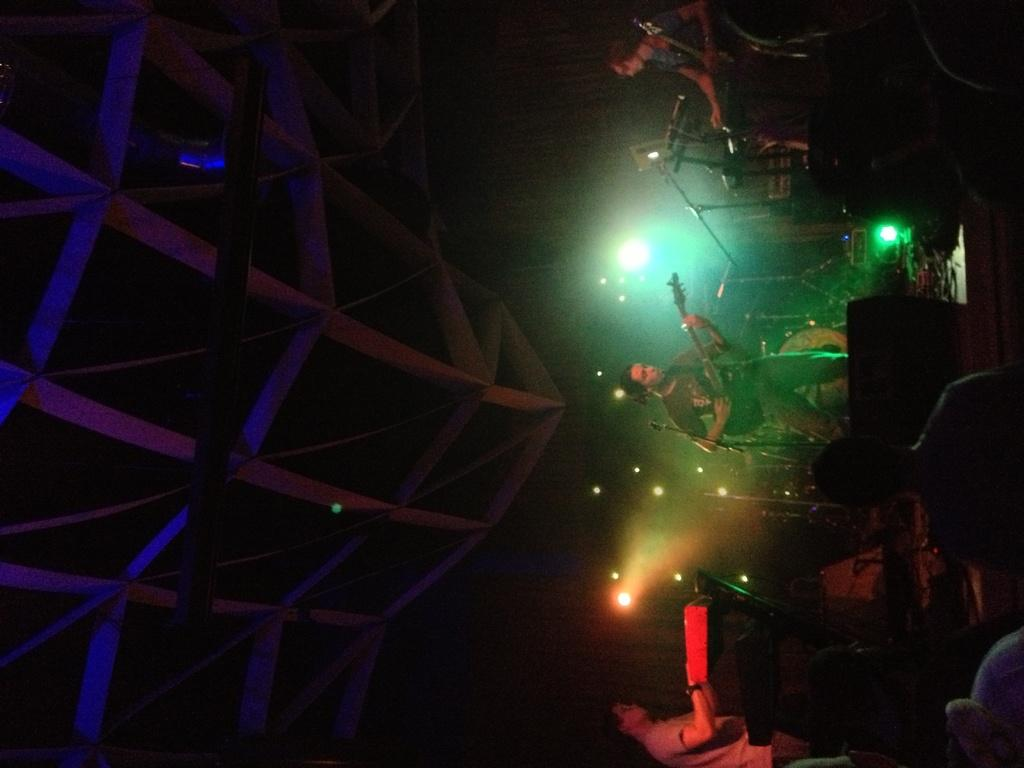What are the people in the image doing? The people in the image are playing musical instruments. What can be seen in addition to the people playing instruments? There are lights visible in the image. Can you describe the overall scene in the image? There are people playing musical instruments, lights, and other unspecified things around in the image. What type of lawyer is present in the image? There is no lawyer present in the image; it features people playing musical instruments and lights. Can you tell me how many beans are visible in the image? There are no beans visible in the image. 